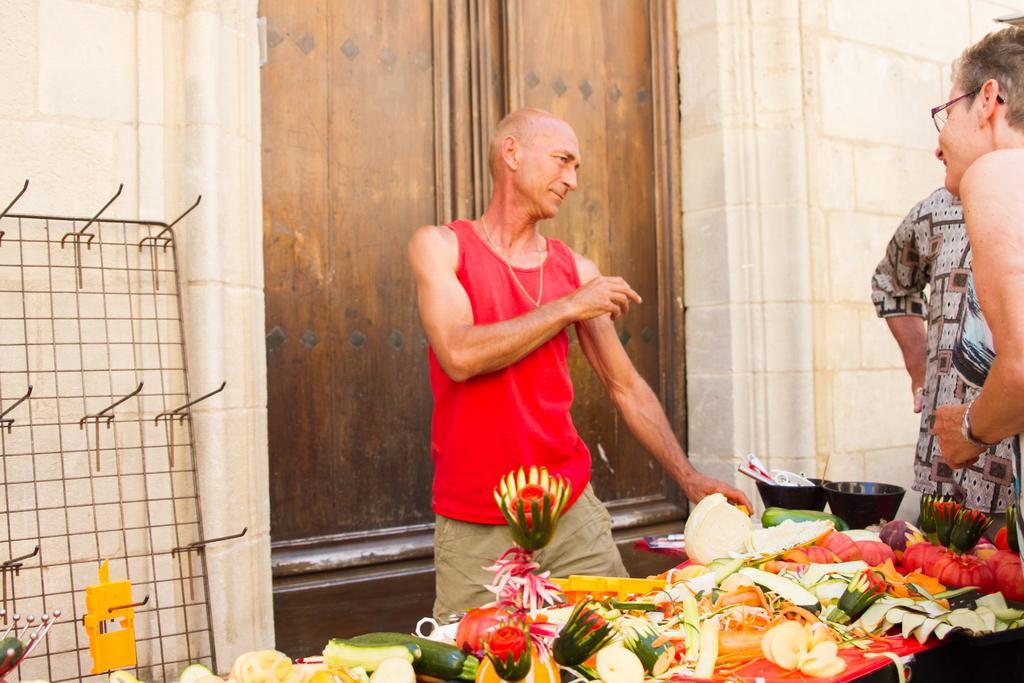Could you give a brief overview of what you see in this image? In this image there are some people standing beside the table on which we can see there are so many chopped vegetables and two bowls with some things, behind them there are doors and grill near the wall. 